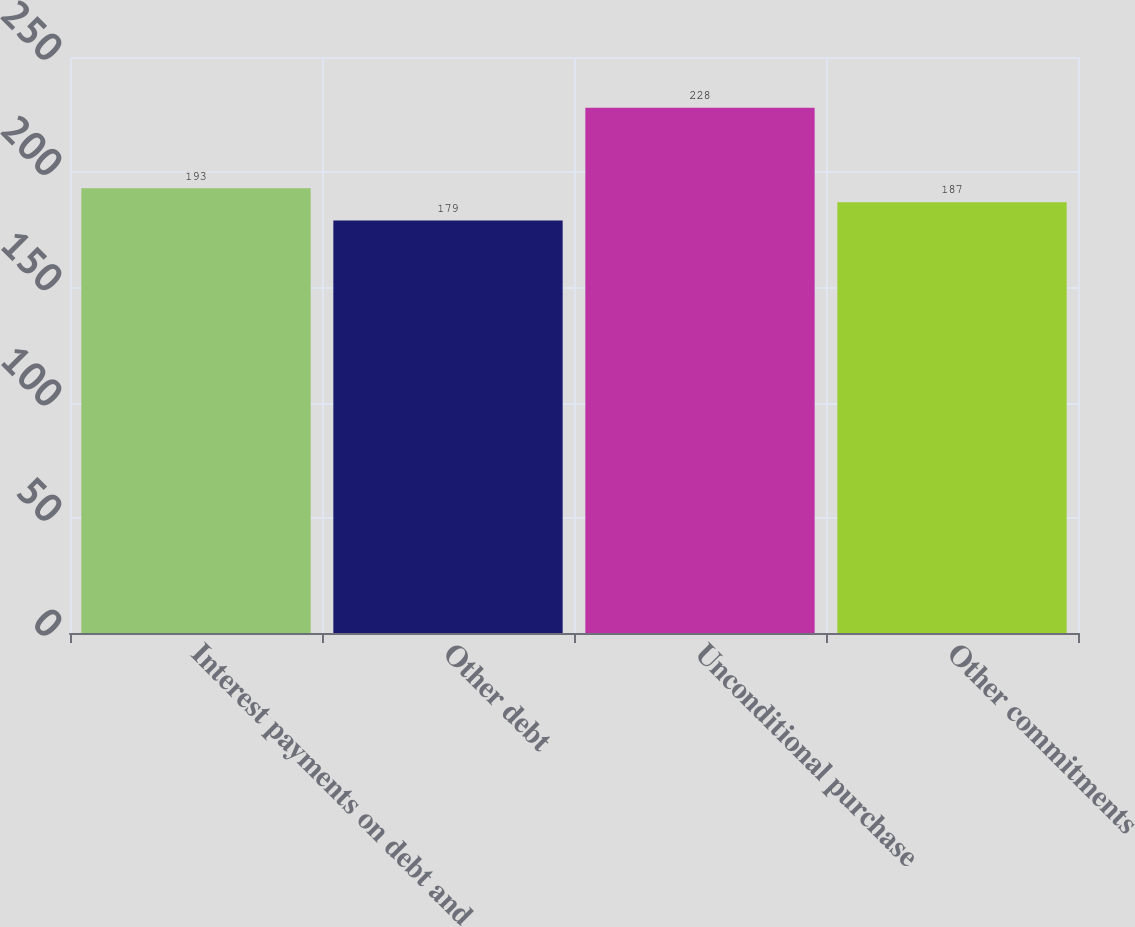<chart> <loc_0><loc_0><loc_500><loc_500><bar_chart><fcel>Interest payments on debt and<fcel>Other debt<fcel>Unconditional purchase<fcel>Other commitments<nl><fcel>193<fcel>179<fcel>228<fcel>187<nl></chart> 